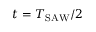<formula> <loc_0><loc_0><loc_500><loc_500>t = T _ { S A W } / 2</formula> 